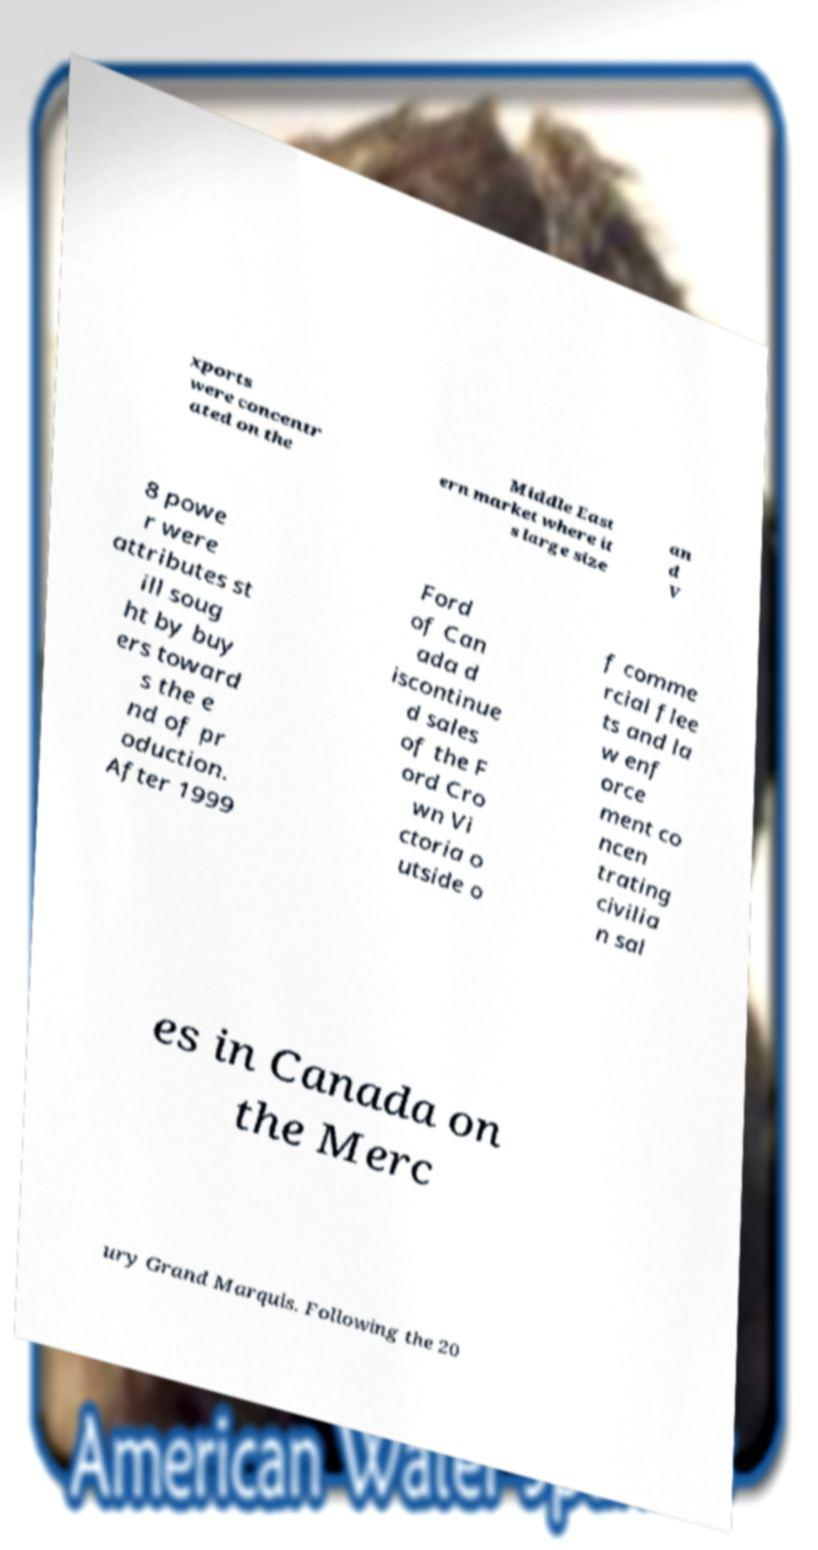Please identify and transcribe the text found in this image. xports were concentr ated on the Middle East ern market where it s large size an d V 8 powe r were attributes st ill soug ht by buy ers toward s the e nd of pr oduction. After 1999 Ford of Can ada d iscontinue d sales of the F ord Cro wn Vi ctoria o utside o f comme rcial flee ts and la w enf orce ment co ncen trating civilia n sal es in Canada on the Merc ury Grand Marquis. Following the 20 